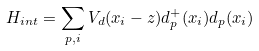Convert formula to latex. <formula><loc_0><loc_0><loc_500><loc_500>H _ { i n t } = \sum _ { p , i } V _ { d } ( x _ { i } - z ) d ^ { + } _ { p } ( x _ { i } ) d _ { p } ( x _ { i } )</formula> 